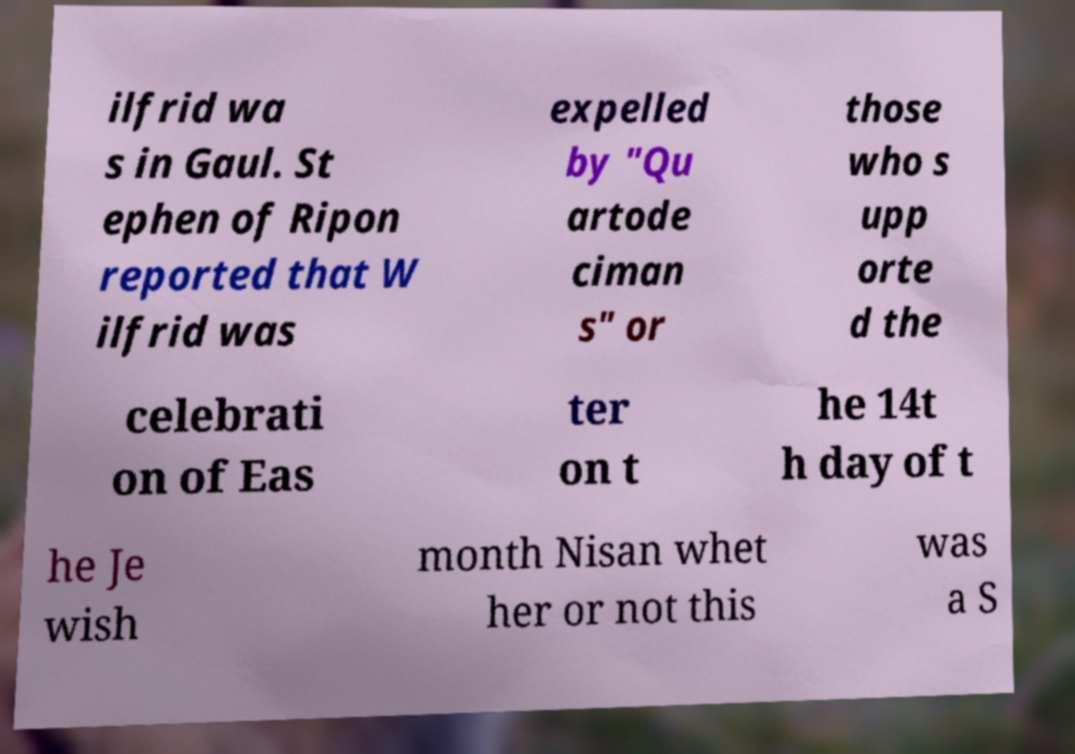There's text embedded in this image that I need extracted. Can you transcribe it verbatim? ilfrid wa s in Gaul. St ephen of Ripon reported that W ilfrid was expelled by "Qu artode ciman s" or those who s upp orte d the celebrati on of Eas ter on t he 14t h day of t he Je wish month Nisan whet her or not this was a S 